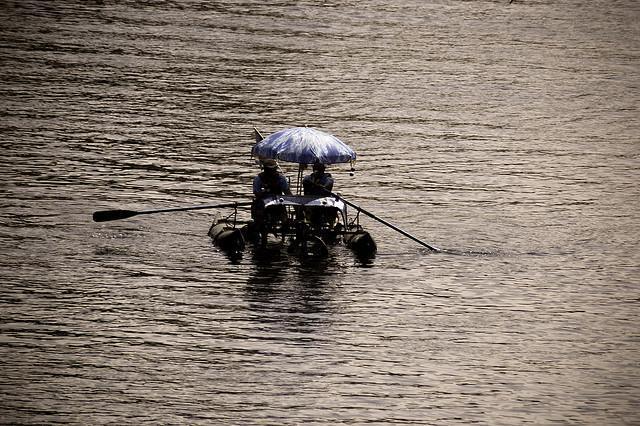How many oars are being used?
Give a very brief answer. 2. How many boats?
Give a very brief answer. 1. How many people are on the boat?
Give a very brief answer. 2. 